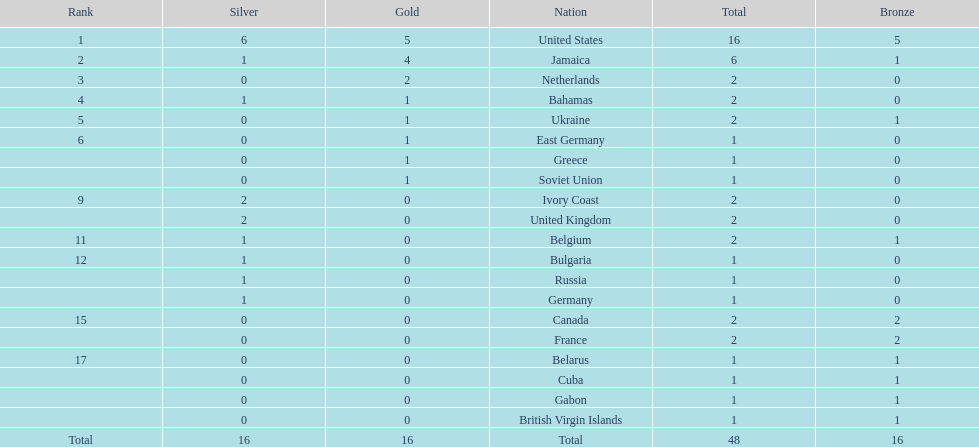How many nations won at least two gold medals? 3. 